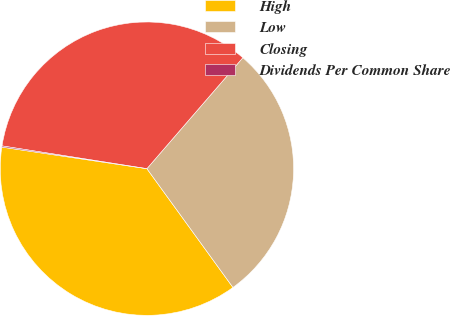Convert chart. <chart><loc_0><loc_0><loc_500><loc_500><pie_chart><fcel>High<fcel>Low<fcel>Closing<fcel>Dividends Per Common Share<nl><fcel>37.33%<fcel>28.68%<fcel>33.87%<fcel>0.13%<nl></chart> 